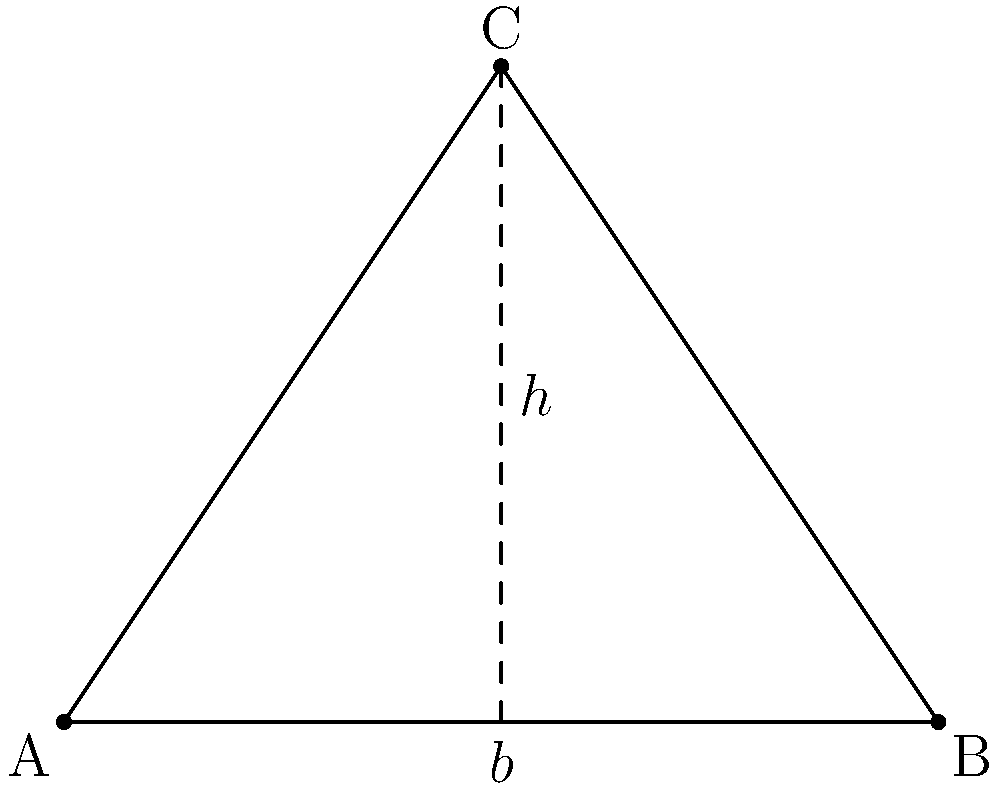In a blood spatter analysis, a triangular pattern is observed on a flat surface. The base of the triangle measures 4 units, and the height is 3 units. What is the area of this triangular blood spatter pattern? To calculate the area of a triangle given its base and height, we can use the following steps:

1. Recall the formula for the area of a triangle:
   $$A = \frac{1}{2} \times b \times h$$
   where $A$ is the area, $b$ is the base, and $h$ is the height.

2. We are given:
   Base $(b) = 4$ units
   Height $(h) = 3$ units

3. Substitute these values into the formula:
   $$A = \frac{1}{2} \times 4 \times 3$$

4. Perform the multiplication:
   $$A = \frac{1}{2} \times 12$$

5. Simplify:
   $$A = 6$$

Therefore, the area of the triangular blood spatter pattern is 6 square units.
Answer: 6 square units 